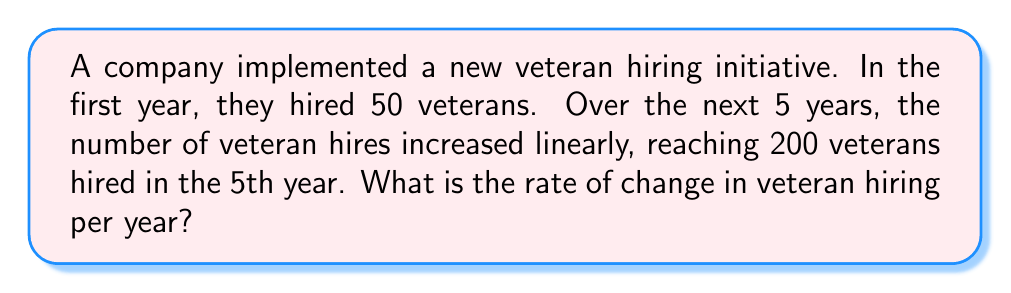Provide a solution to this math problem. To solve this problem, we need to use the concept of rate of change in a linear equation. Let's approach this step-by-step:

1) We have two points:
   - Year 1: 50 veterans hired
   - Year 5: 200 veterans hired

2) The rate of change (m) in a linear equation is given by the formula:

   $$m = \frac{y_2 - y_1}{x_2 - x_1}$$

   Where $(x_1, y_1)$ and $(x_2, y_2)$ are two points on the line.

3) Let's plug in our values:
   $x_1 = 1$, $y_1 = 50$ (Year 1, 50 veterans)
   $x_2 = 5$, $y_2 = 200$ (Year 5, 200 veterans)

4) Now, let's calculate:

   $$m = \frac{200 - 50}{5 - 1} = \frac{150}{4} = 37.5$$

5) This means that the number of veteran hires is increasing by 37.5 per year.
Answer: 37.5 veterans per year 